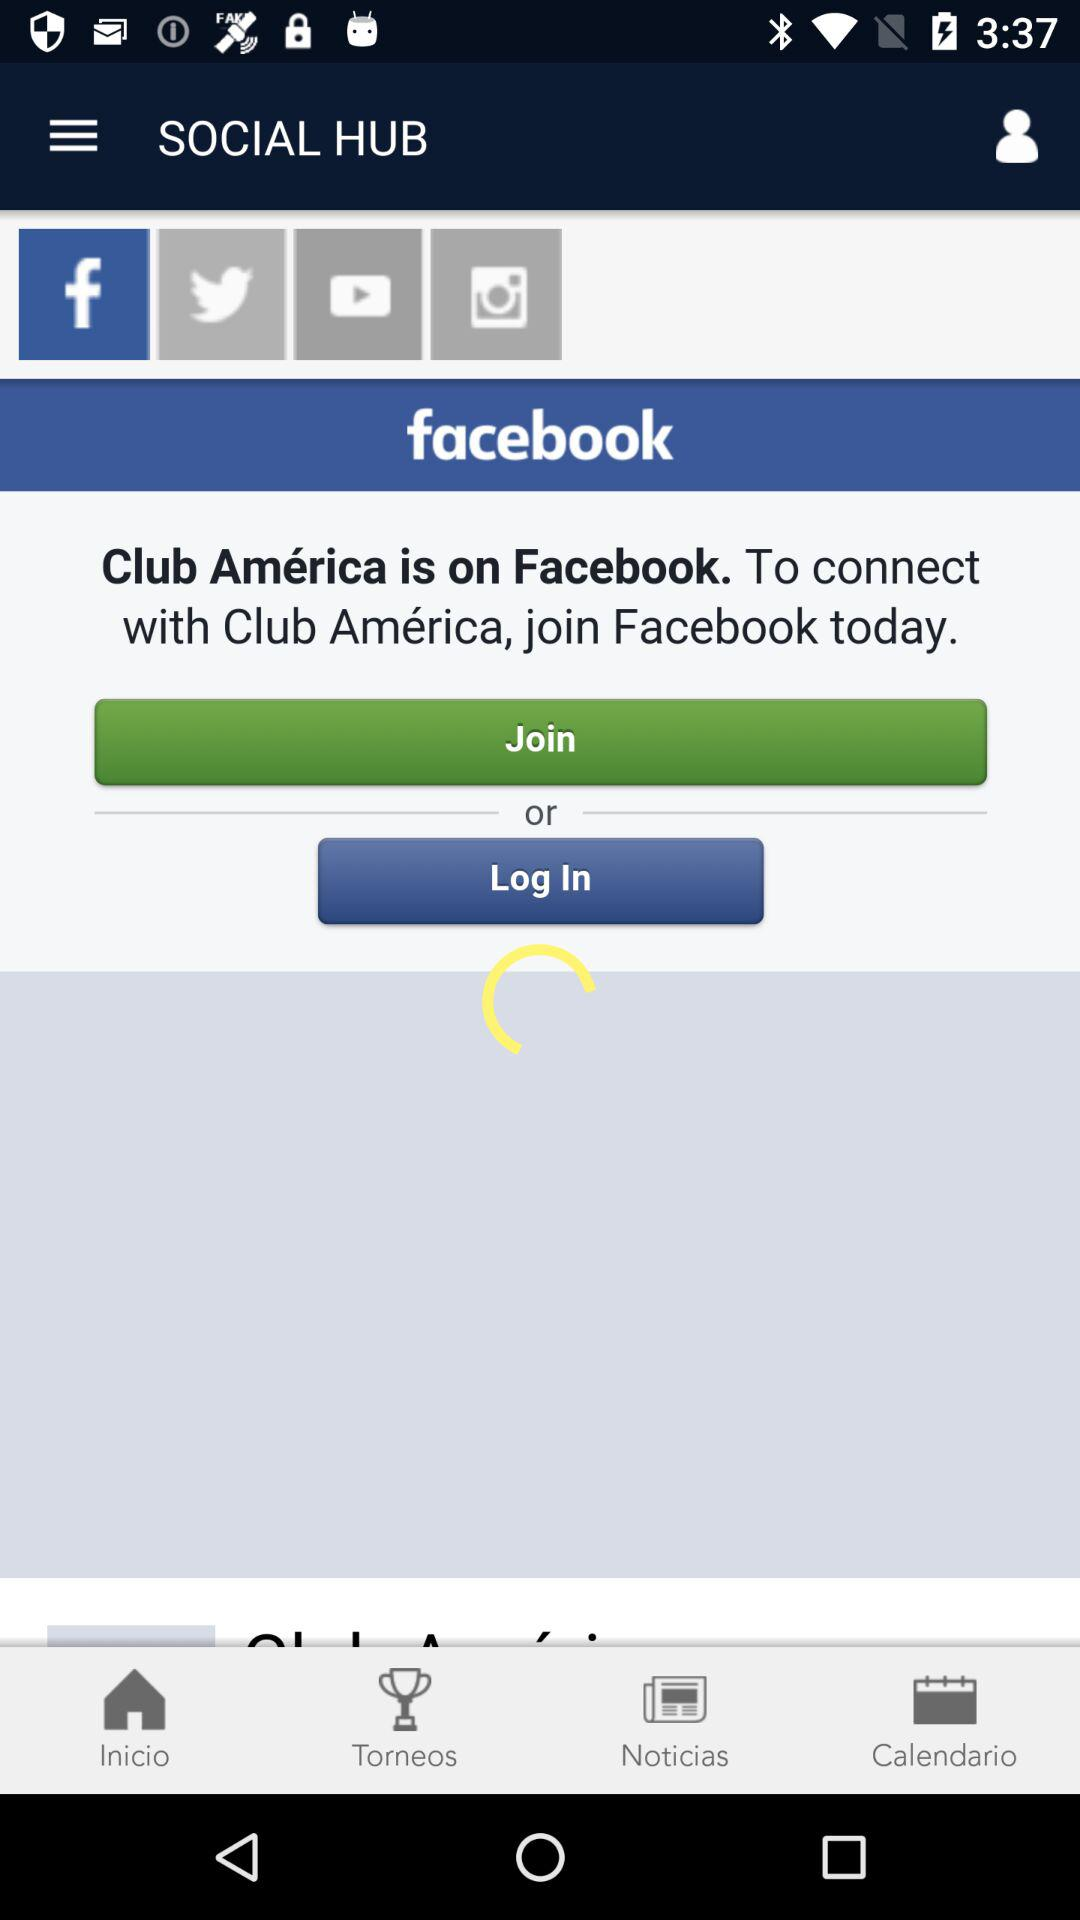What application can be used to log in to a profile? The application that can be used to log in to a profile is "facebook". 